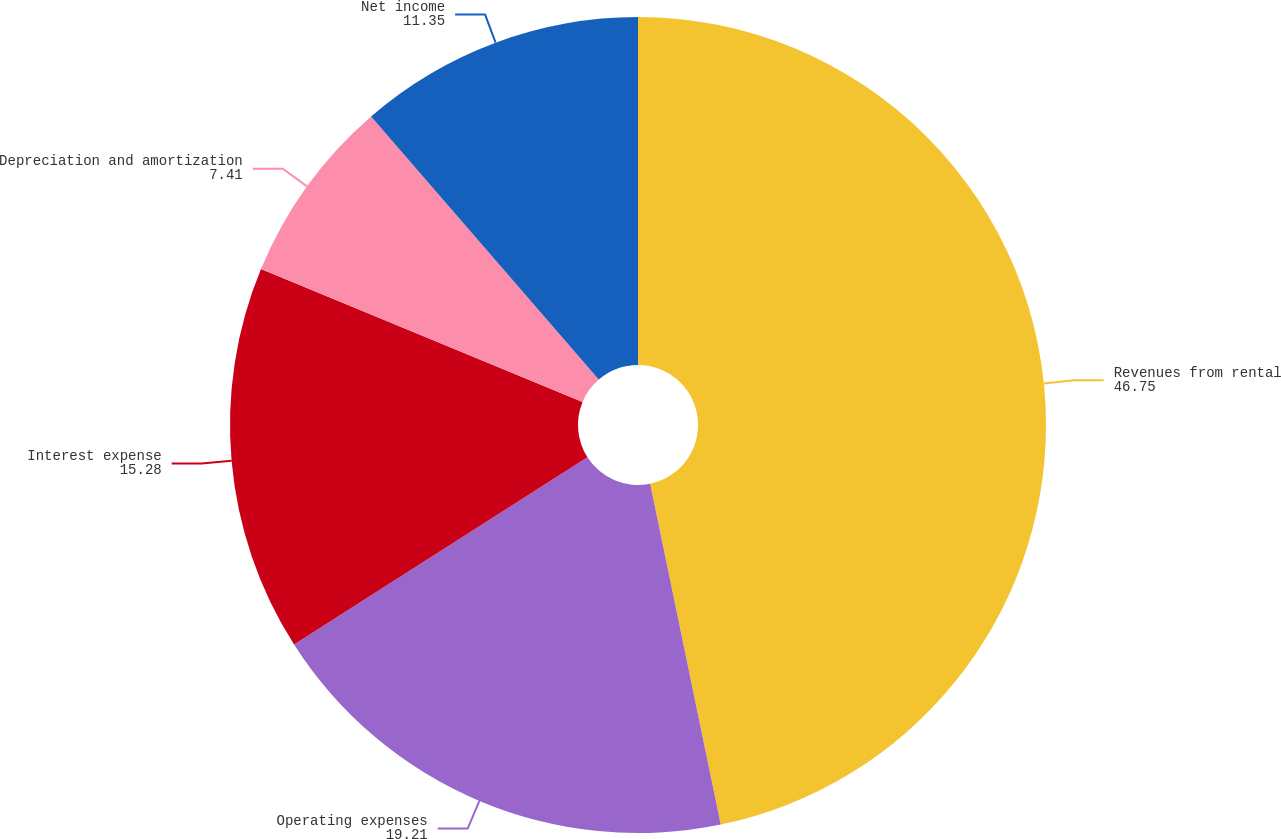Convert chart. <chart><loc_0><loc_0><loc_500><loc_500><pie_chart><fcel>Revenues from rental<fcel>Operating expenses<fcel>Interest expense<fcel>Depreciation and amortization<fcel>Net income<nl><fcel>46.75%<fcel>19.21%<fcel>15.28%<fcel>7.41%<fcel>11.35%<nl></chart> 